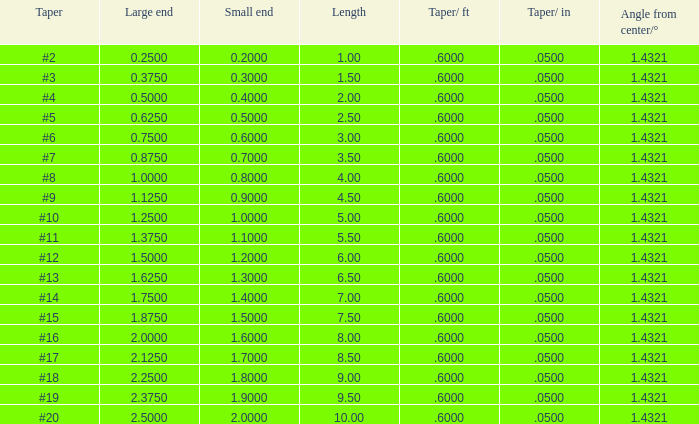Which big end possesses a taper/ft less than 19.0. 